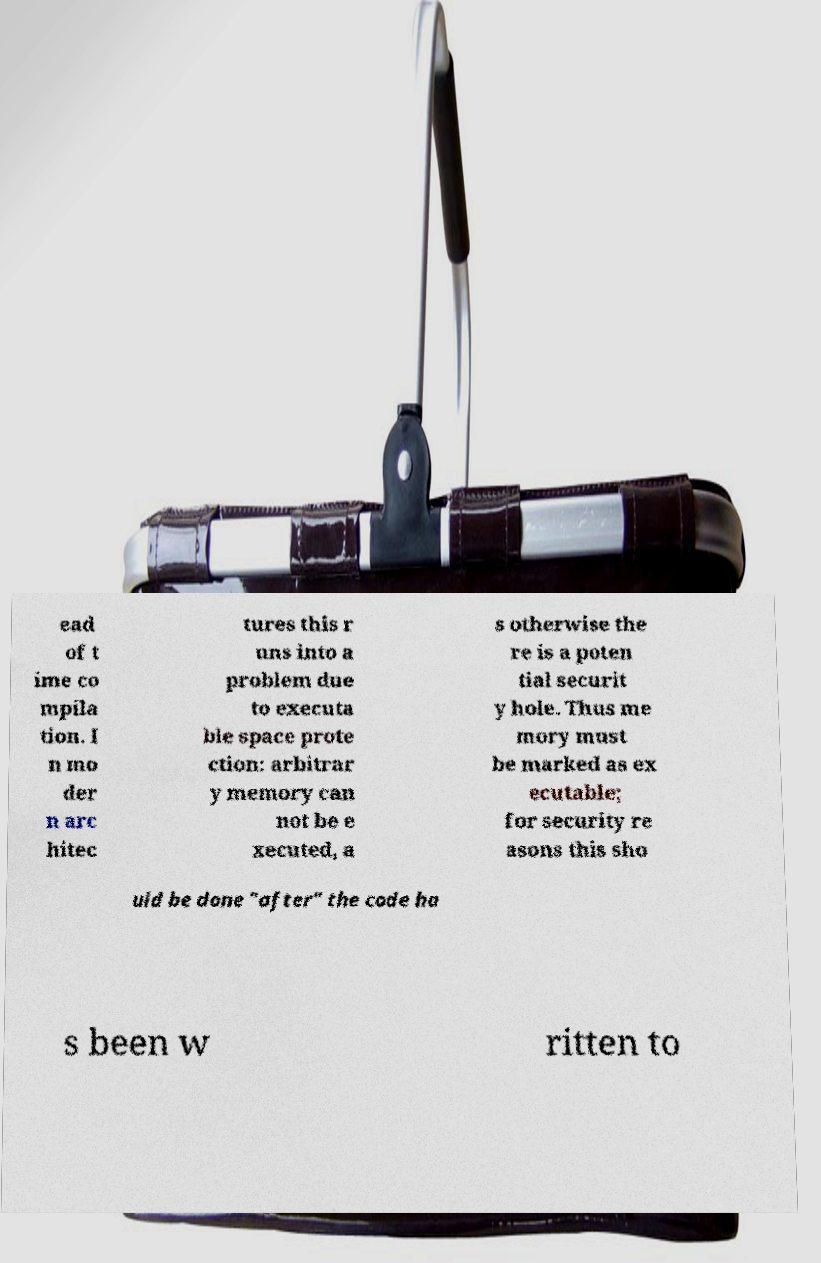For documentation purposes, I need the text within this image transcribed. Could you provide that? ead of t ime co mpila tion. I n mo der n arc hitec tures this r uns into a problem due to executa ble space prote ction: arbitrar y memory can not be e xecuted, a s otherwise the re is a poten tial securit y hole. Thus me mory must be marked as ex ecutable; for security re asons this sho uld be done "after" the code ha s been w ritten to 